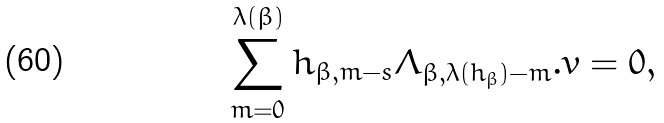Convert formula to latex. <formula><loc_0><loc_0><loc_500><loc_500>\sum _ { m = 0 } ^ { \lambda ( \beta ) } h _ { \beta , m - s } \Lambda _ { \beta , \lambda ( h _ { \beta } ) - m } . v = 0 ,</formula> 